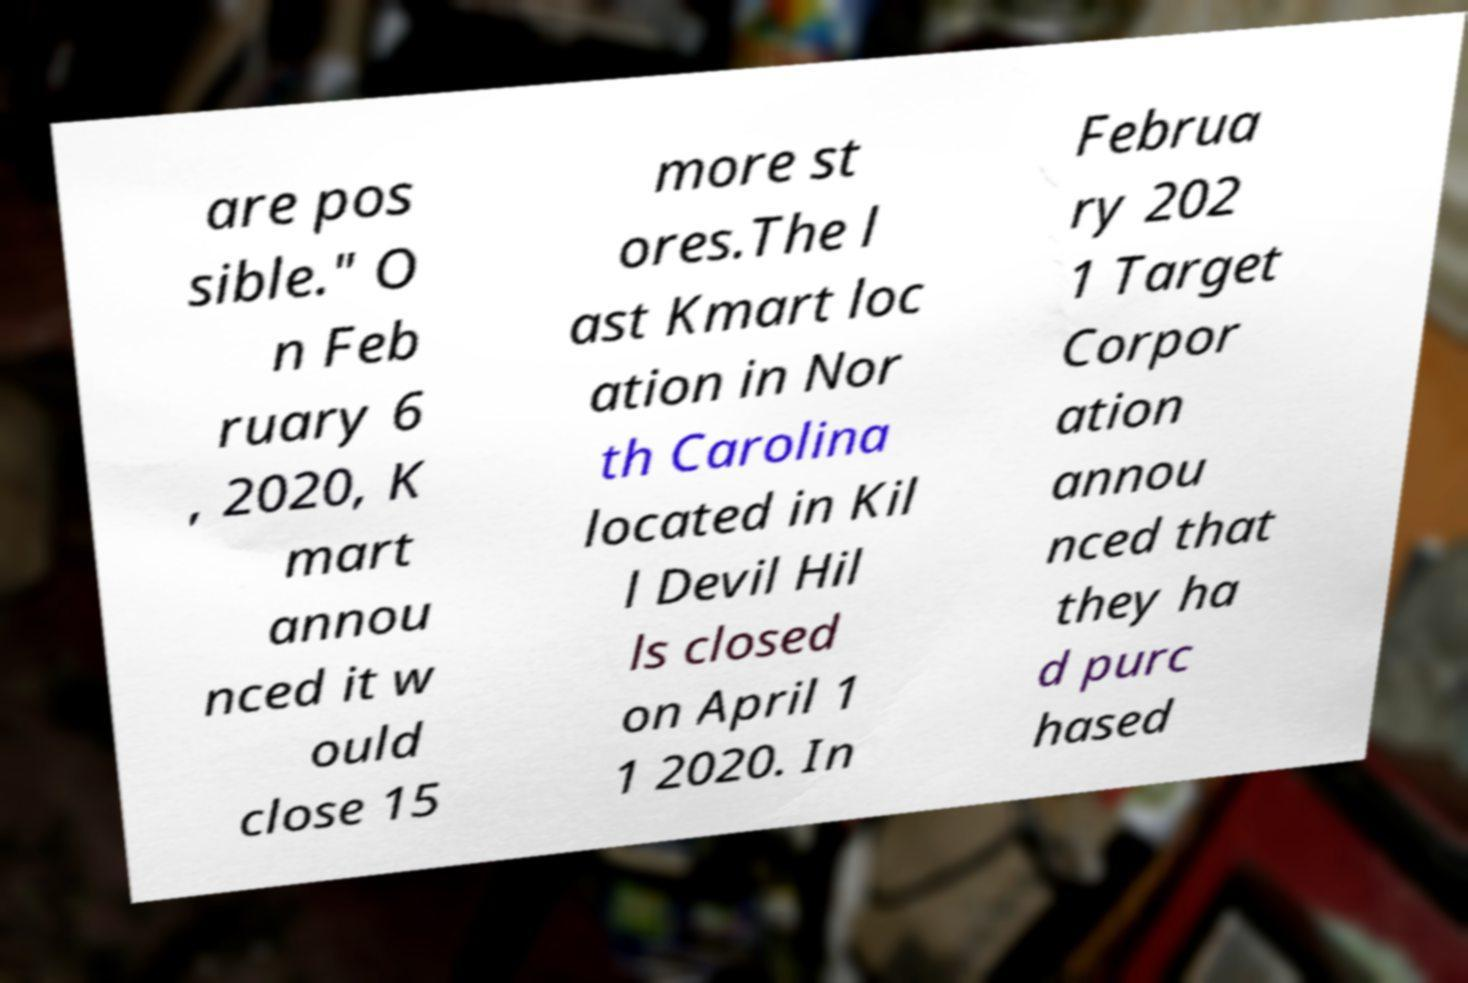Can you read and provide the text displayed in the image?This photo seems to have some interesting text. Can you extract and type it out for me? are pos sible." O n Feb ruary 6 , 2020, K mart annou nced it w ould close 15 more st ores.The l ast Kmart loc ation in Nor th Carolina located in Kil l Devil Hil ls closed on April 1 1 2020. In Februa ry 202 1 Target Corpor ation annou nced that they ha d purc hased 